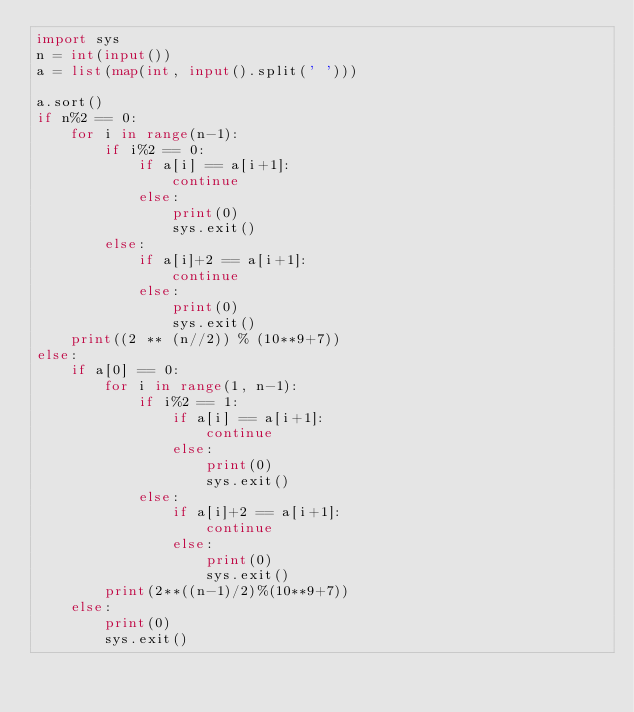<code> <loc_0><loc_0><loc_500><loc_500><_Python_>import sys
n = int(input())
a = list(map(int, input().split(' ')))

a.sort()
if n%2 == 0:
    for i in range(n-1):
        if i%2 == 0:
            if a[i] == a[i+1]:
                continue
            else:
                print(0)
                sys.exit()
        else:
            if a[i]+2 == a[i+1]:
                continue
            else:
                print(0)
                sys.exit()
    print((2 ** (n//2)) % (10**9+7))
else:
    if a[0] == 0:
        for i in range(1, n-1):
            if i%2 == 1:
                if a[i] == a[i+1]:
                    continue
                else:
                    print(0)
                    sys.exit()
            else:
                if a[i]+2 == a[i+1]:
                    continue
                else:
                    print(0)
                    sys.exit()
        print(2**((n-1)/2)%(10**9+7))
    else:
        print(0)
        sys.exit()</code> 